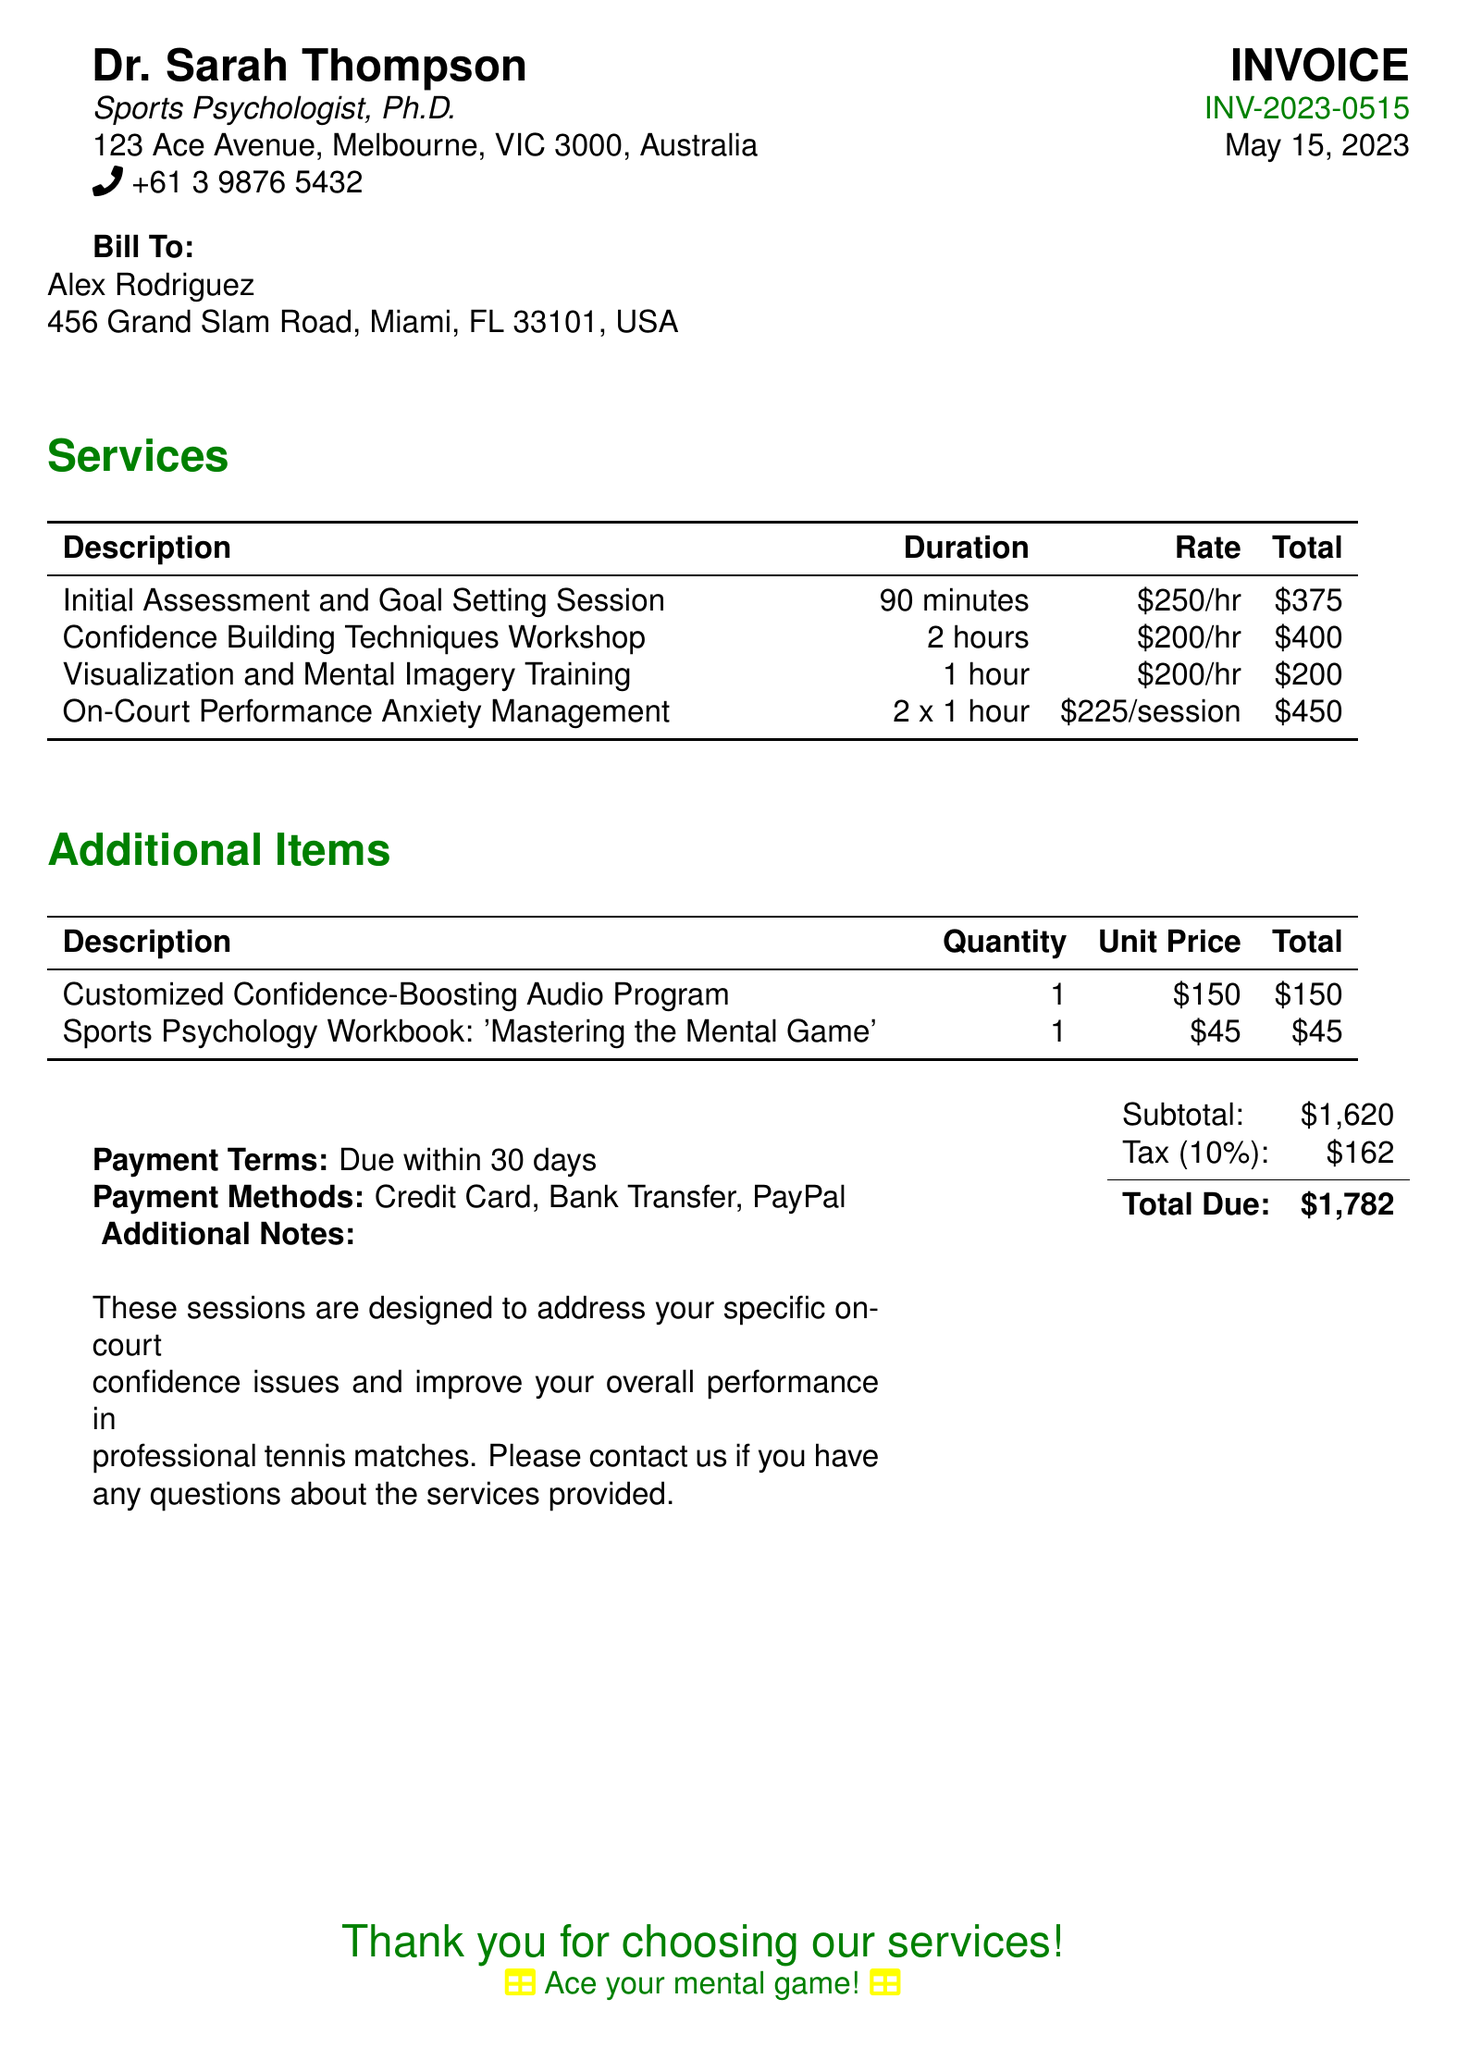What is the name of the sports psychologist? The name of the sports psychologist listed in the document is Dr. Sarah Thompson.
Answer: Dr. Sarah Thompson What is the total amount due? The total amount due is provided at the bottom of the document and includes the subtotal and tax.
Answer: $1,782 How many hours is the Confidence Building Techniques Workshop? The duration of the Confidence Building Techniques Workshop is specified in the services section of the document.
Answer: 2 hours What is the unit price of the Sports Psychology Workbook? The unit price for the Sports Psychology Workbook is noted in the additional items section.
Answer: $45 What is the duration of the Initial Assessment and Goal Setting Session? The duration of the Initial Assessment and Goal Setting Session is mentioned with details of the services provided.
Answer: 90 minutes What payment methods are accepted? The payment methods that can be used are listed under payment terms in the document.
Answer: Credit Card, Bank Transfer, PayPal What is included in the customized audio program? The document states that the audio program is designed to boost confidence specifically for on-court performance.
Answer: Customized Confidence-Boosting Audio Program How many on-court performance anxiety management sessions are included? The number of sessions for on-court performance anxiety management is listed in the services section.
Answer: 2 sessions When is payment due? The payment terms state when the payment is expected to be made, which is also specified in the document.
Answer: Due within 30 days 